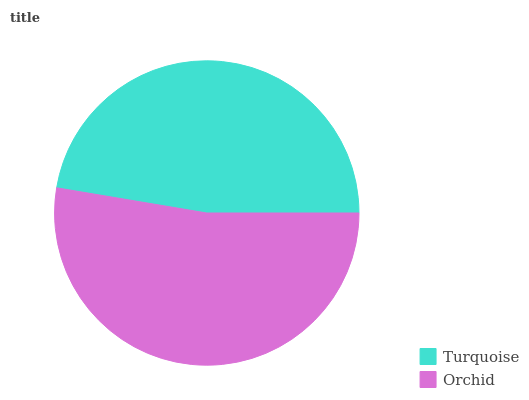Is Turquoise the minimum?
Answer yes or no. Yes. Is Orchid the maximum?
Answer yes or no. Yes. Is Orchid the minimum?
Answer yes or no. No. Is Orchid greater than Turquoise?
Answer yes or no. Yes. Is Turquoise less than Orchid?
Answer yes or no. Yes. Is Turquoise greater than Orchid?
Answer yes or no. No. Is Orchid less than Turquoise?
Answer yes or no. No. Is Orchid the high median?
Answer yes or no. Yes. Is Turquoise the low median?
Answer yes or no. Yes. Is Turquoise the high median?
Answer yes or no. No. Is Orchid the low median?
Answer yes or no. No. 